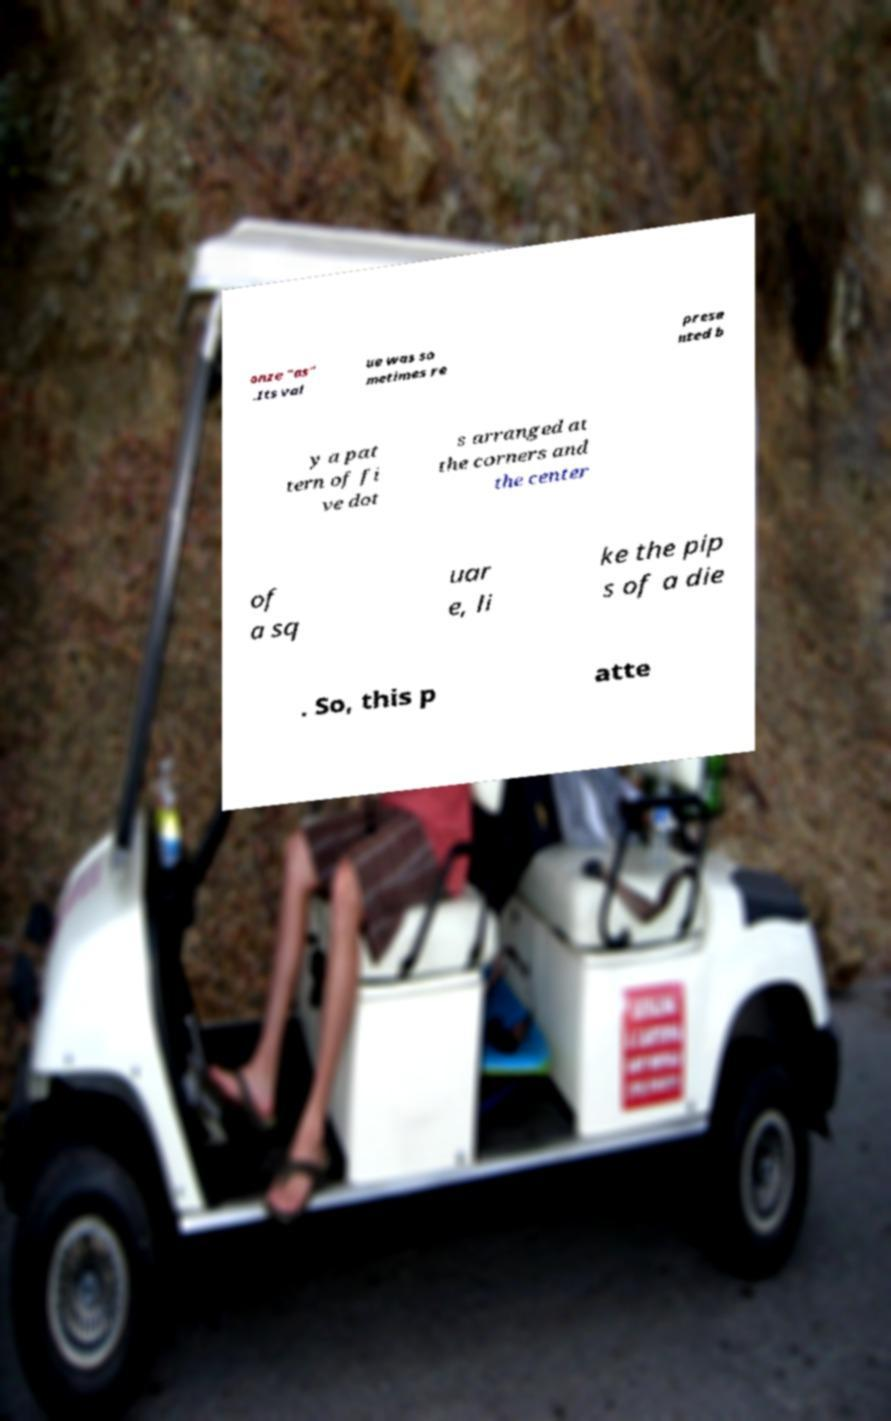Can you accurately transcribe the text from the provided image for me? onze "as" .Its val ue was so metimes re prese nted b y a pat tern of fi ve dot s arranged at the corners and the center of a sq uar e, li ke the pip s of a die . So, this p atte 